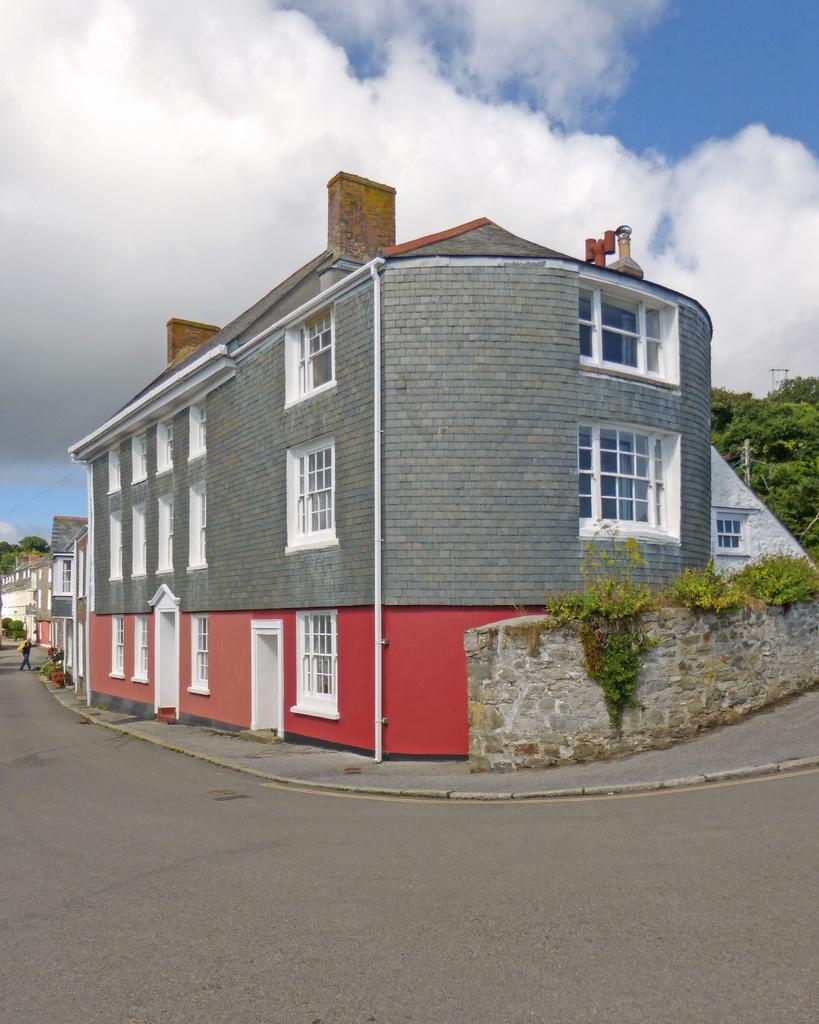What type of structures can be seen in the image? There are buildings in the image. What natural elements are present in the image? There are trees in the image. What architectural feature is visible in the image? There is a wall in the image. Can you describe the person's activity in the background of the image? A person is walking in the background of the image. How would you describe the weather based on the image? The sky is cloudy in the image. Where is the goat located in the image? There is no goat present in the image. What type of service is the person offering in the image? There is no person offering any service in the image; the person is simply walking in the background. 